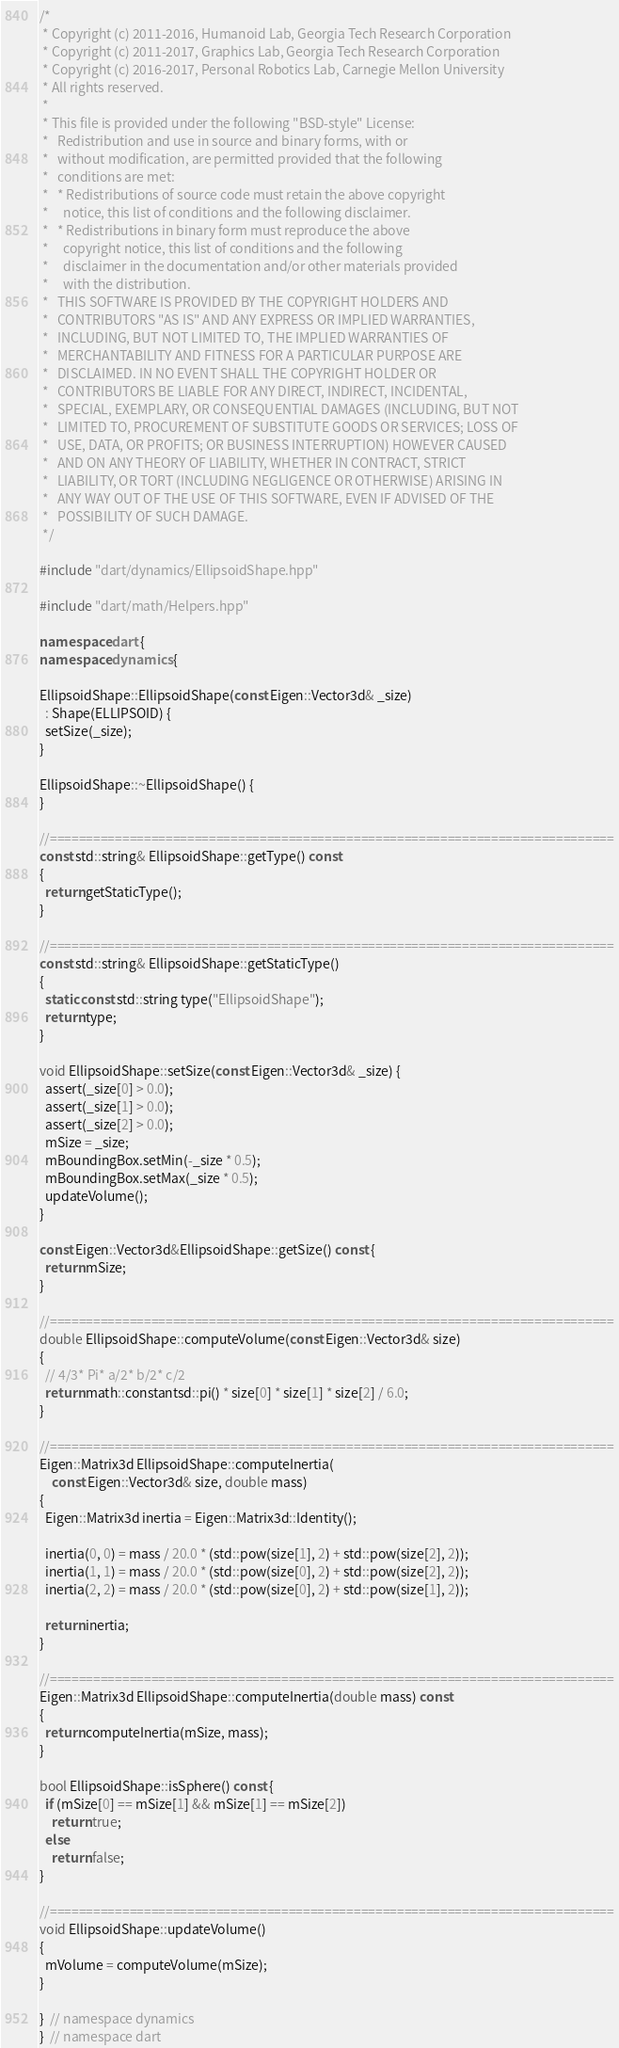<code> <loc_0><loc_0><loc_500><loc_500><_C++_>/*
 * Copyright (c) 2011-2016, Humanoid Lab, Georgia Tech Research Corporation
 * Copyright (c) 2011-2017, Graphics Lab, Georgia Tech Research Corporation
 * Copyright (c) 2016-2017, Personal Robotics Lab, Carnegie Mellon University
 * All rights reserved.
 *
 * This file is provided under the following "BSD-style" License:
 *   Redistribution and use in source and binary forms, with or
 *   without modification, are permitted provided that the following
 *   conditions are met:
 *   * Redistributions of source code must retain the above copyright
 *     notice, this list of conditions and the following disclaimer.
 *   * Redistributions in binary form must reproduce the above
 *     copyright notice, this list of conditions and the following
 *     disclaimer in the documentation and/or other materials provided
 *     with the distribution.
 *   THIS SOFTWARE IS PROVIDED BY THE COPYRIGHT HOLDERS AND
 *   CONTRIBUTORS "AS IS" AND ANY EXPRESS OR IMPLIED WARRANTIES,
 *   INCLUDING, BUT NOT LIMITED TO, THE IMPLIED WARRANTIES OF
 *   MERCHANTABILITY AND FITNESS FOR A PARTICULAR PURPOSE ARE
 *   DISCLAIMED. IN NO EVENT SHALL THE COPYRIGHT HOLDER OR
 *   CONTRIBUTORS BE LIABLE FOR ANY DIRECT, INDIRECT, INCIDENTAL,
 *   SPECIAL, EXEMPLARY, OR CONSEQUENTIAL DAMAGES (INCLUDING, BUT NOT
 *   LIMITED TO, PROCUREMENT OF SUBSTITUTE GOODS OR SERVICES; LOSS OF
 *   USE, DATA, OR PROFITS; OR BUSINESS INTERRUPTION) HOWEVER CAUSED
 *   AND ON ANY THEORY OF LIABILITY, WHETHER IN CONTRACT, STRICT
 *   LIABILITY, OR TORT (INCLUDING NEGLIGENCE OR OTHERWISE) ARISING IN
 *   ANY WAY OUT OF THE USE OF THIS SOFTWARE, EVEN IF ADVISED OF THE
 *   POSSIBILITY OF SUCH DAMAGE.
 */

#include "dart/dynamics/EllipsoidShape.hpp"

#include "dart/math/Helpers.hpp"

namespace dart {
namespace dynamics {

EllipsoidShape::EllipsoidShape(const Eigen::Vector3d& _size)
  : Shape(ELLIPSOID) {
  setSize(_size);
}

EllipsoidShape::~EllipsoidShape() {
}

//==============================================================================
const std::string& EllipsoidShape::getType() const
{
  return getStaticType();
}

//==============================================================================
const std::string& EllipsoidShape::getStaticType()
{
  static const std::string type("EllipsoidShape");
  return type;
}

void EllipsoidShape::setSize(const Eigen::Vector3d& _size) {
  assert(_size[0] > 0.0);
  assert(_size[1] > 0.0);
  assert(_size[2] > 0.0);
  mSize = _size;
  mBoundingBox.setMin(-_size * 0.5);
  mBoundingBox.setMax(_size * 0.5);
  updateVolume();
}

const Eigen::Vector3d&EllipsoidShape::getSize() const {
  return mSize;
}

//==============================================================================
double EllipsoidShape::computeVolume(const Eigen::Vector3d& size)
{
  // 4/3* Pi* a/2* b/2* c/2
  return math::constantsd::pi() * size[0] * size[1] * size[2] / 6.0;
}

//==============================================================================
Eigen::Matrix3d EllipsoidShape::computeInertia(
    const Eigen::Vector3d& size, double mass)
{
  Eigen::Matrix3d inertia = Eigen::Matrix3d::Identity();

  inertia(0, 0) = mass / 20.0 * (std::pow(size[1], 2) + std::pow(size[2], 2));
  inertia(1, 1) = mass / 20.0 * (std::pow(size[0], 2) + std::pow(size[2], 2));
  inertia(2, 2) = mass / 20.0 * (std::pow(size[0], 2) + std::pow(size[1], 2));

  return inertia;
}

//==============================================================================
Eigen::Matrix3d EllipsoidShape::computeInertia(double mass) const
{
  return computeInertia(mSize, mass);
}

bool EllipsoidShape::isSphere() const {
  if (mSize[0] == mSize[1] && mSize[1] == mSize[2])
    return true;
  else
    return false;
}

//==============================================================================
void EllipsoidShape::updateVolume()
{
  mVolume = computeVolume(mSize);
}

}  // namespace dynamics
}  // namespace dart
</code> 